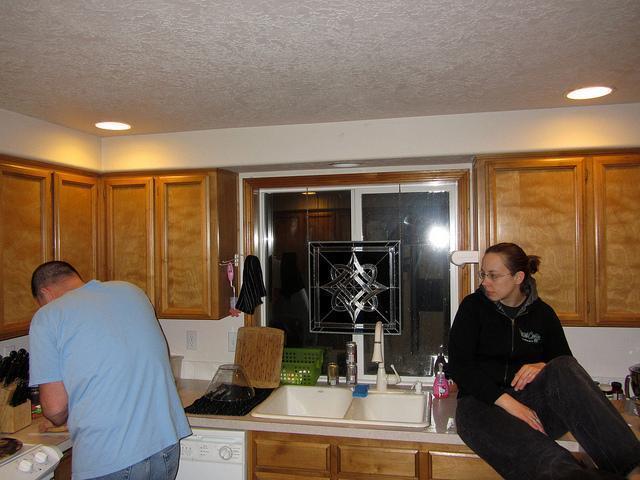How many people are in the photo?
Give a very brief answer. 2. How many keyboards are there?
Give a very brief answer. 0. 